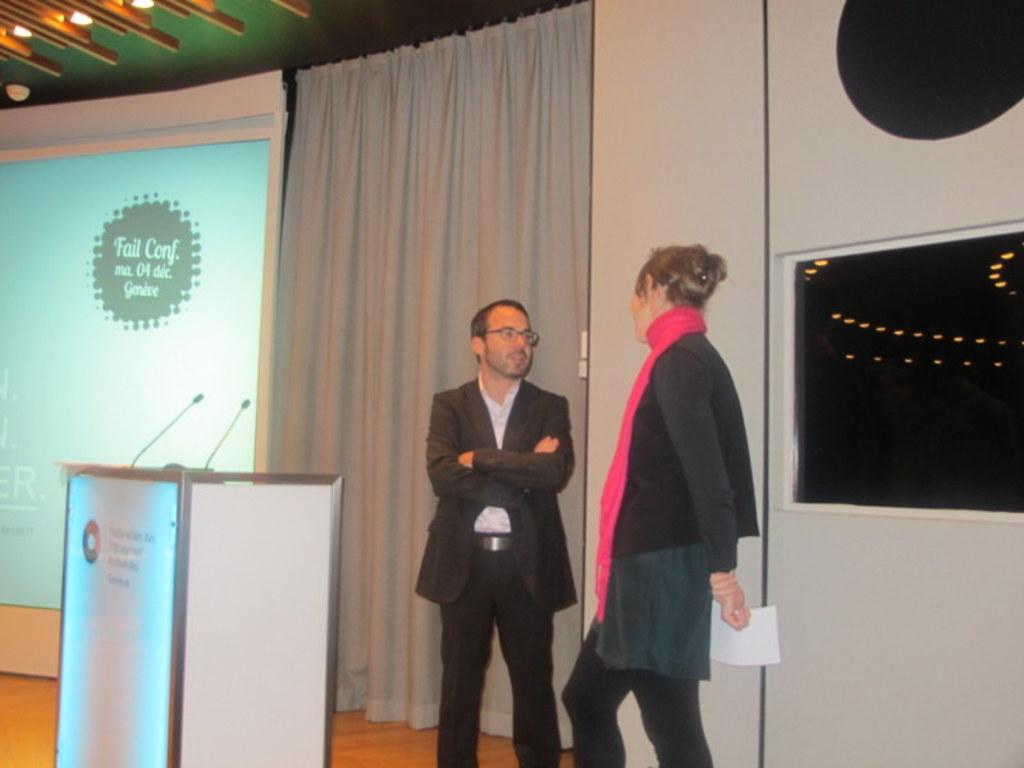Where will the conference take place?
Make the answer very short. Unanswerable. 